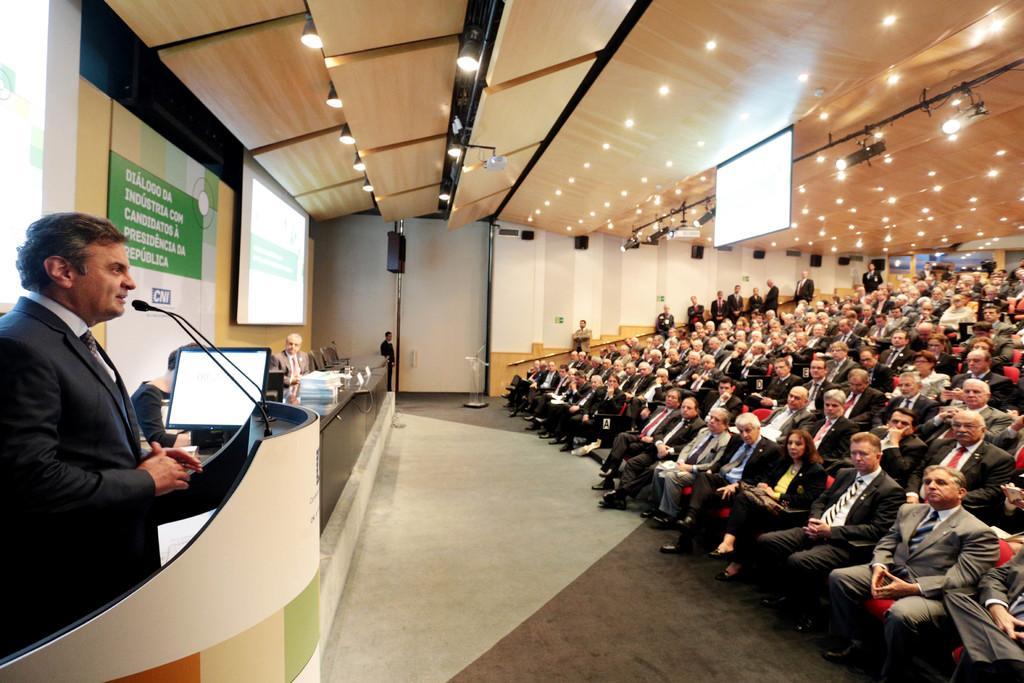Please provide a concise description of this image. this is the man speaking, this is the microphone and the system, these are the chairs in the opposite audience are sitting listening to this man, they are sitting on a read chair, man wearing blazer and black shoes, a tie, pant. brown hair , this is the projected screen and lights. 